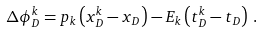<formula> <loc_0><loc_0><loc_500><loc_500>\Delta \phi _ { D } ^ { k } = p _ { k } \left ( x _ { D } ^ { k } - x _ { D } \right ) - E _ { k } \left ( t _ { D } ^ { k } - t _ { D } \right ) \, .</formula> 